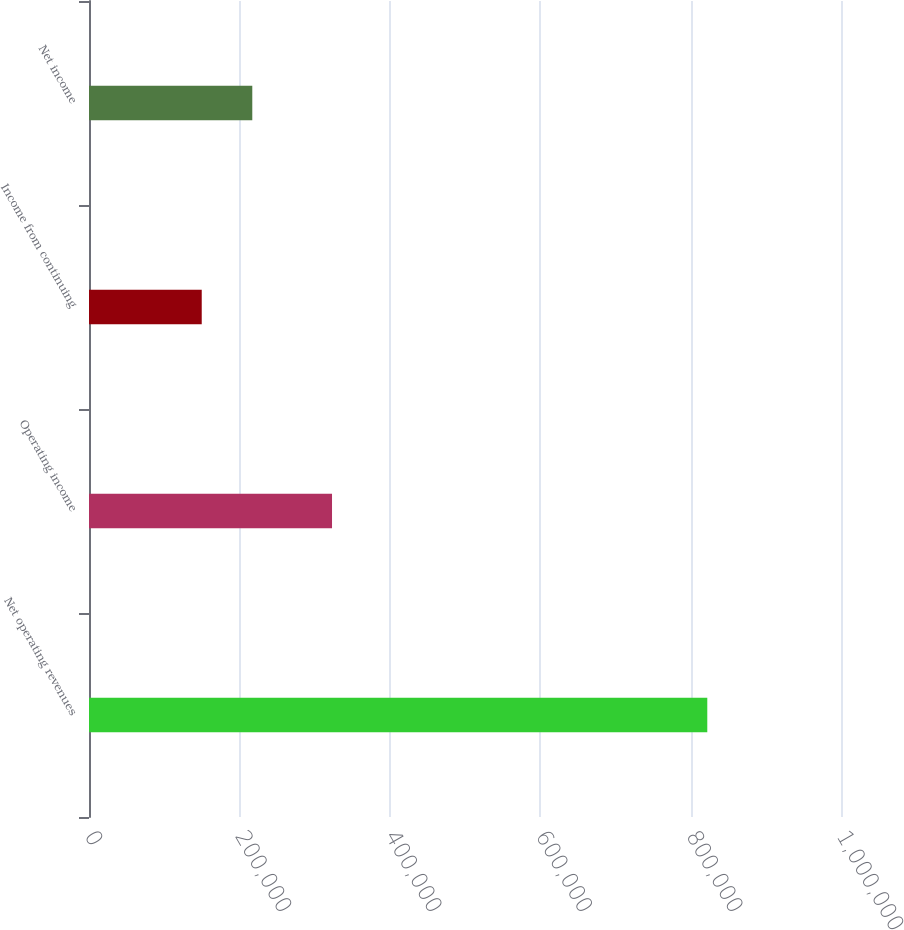Convert chart. <chart><loc_0><loc_0><loc_500><loc_500><bar_chart><fcel>Net operating revenues<fcel>Operating income<fcel>Income from continuing<fcel>Net income<nl><fcel>822190<fcel>323166<fcel>149909<fcel>217137<nl></chart> 